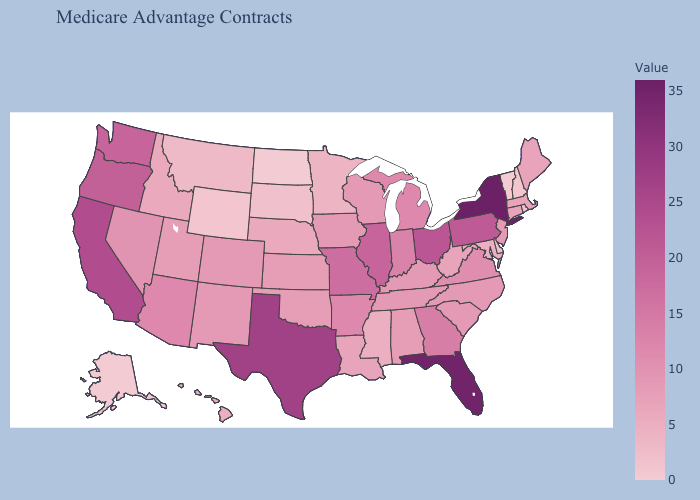Does Georgia have the lowest value in the USA?
Be succinct. No. Among the states that border Maryland , which have the highest value?
Answer briefly. Pennsylvania. Does Vermont have the highest value in the USA?
Give a very brief answer. No. Does Connecticut have a lower value than Georgia?
Give a very brief answer. Yes. 